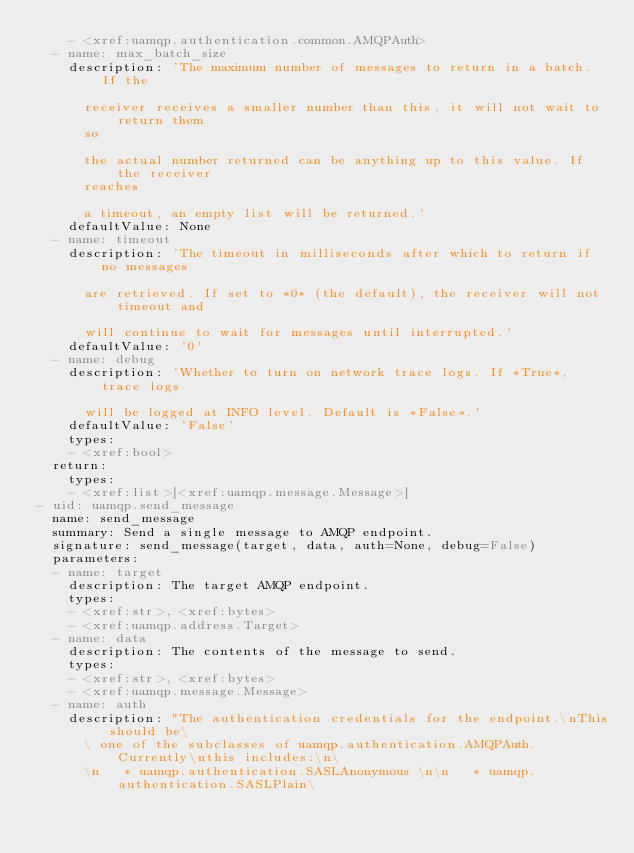Convert code to text. <code><loc_0><loc_0><loc_500><loc_500><_YAML_>    - <xref:uamqp.authentication.common.AMQPAuth>
  - name: max_batch_size
    description: 'The maximum number of messages to return in a batch. If the

      receiver receives a smaller number than this, it will not wait to return them
      so

      the actual number returned can be anything up to this value. If the receiver
      reaches

      a timeout, an empty list will be returned.'
    defaultValue: None
  - name: timeout
    description: 'The timeout in milliseconds after which to return if no messages

      are retrieved. If set to *0* (the default), the receiver will not timeout and

      will continue to wait for messages until interrupted.'
    defaultValue: '0'
  - name: debug
    description: 'Whether to turn on network trace logs. If *True*, trace logs

      will be logged at INFO level. Default is *False*.'
    defaultValue: 'False'
    types:
    - <xref:bool>
  return:
    types:
    - <xref:list>[<xref:uamqp.message.Message>]
- uid: uamqp.send_message
  name: send_message
  summary: Send a single message to AMQP endpoint.
  signature: send_message(target, data, auth=None, debug=False)
  parameters:
  - name: target
    description: The target AMQP endpoint.
    types:
    - <xref:str>, <xref:bytes>
    - <xref:uamqp.address.Target>
  - name: data
    description: The contents of the message to send.
    types:
    - <xref:str>, <xref:bytes>
    - <xref:uamqp.message.Message>
  - name: auth
    description: "The authentication credentials for the endpoint.\nThis should be\
      \ one of the subclasses of uamqp.authentication.AMQPAuth. Currently\nthis includes:\n\
      \n   * uamqp.authentication.SASLAnonymous \n\n   * uamqp.authentication.SASLPlain\</code> 